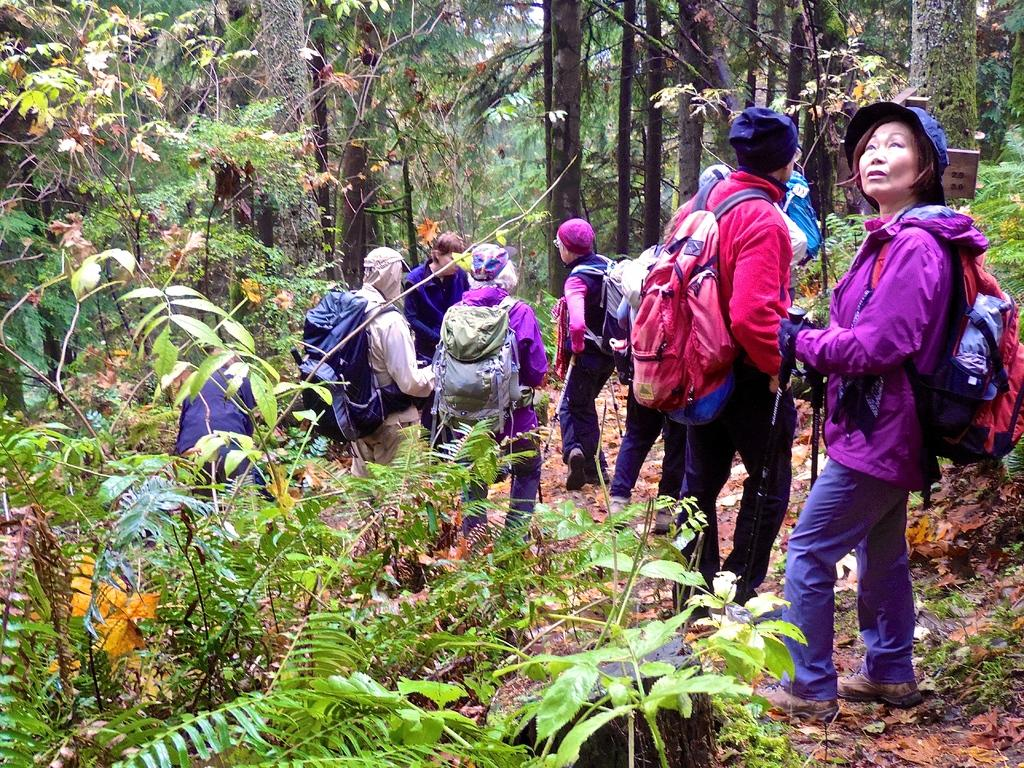How many people are in the image? There is a group of persons in the image. What are the persons in the image doing? The persons are walking. What can be seen on both sides of the image? There are trees on the left side and the right side of the image. What is visible in the background of the image? There are trees and the sky visible in the background of the image. What type of veil can be seen covering the structure in the image? There is no veil or structure present in the image; it features a group of persons walking amidst trees and the sky. 